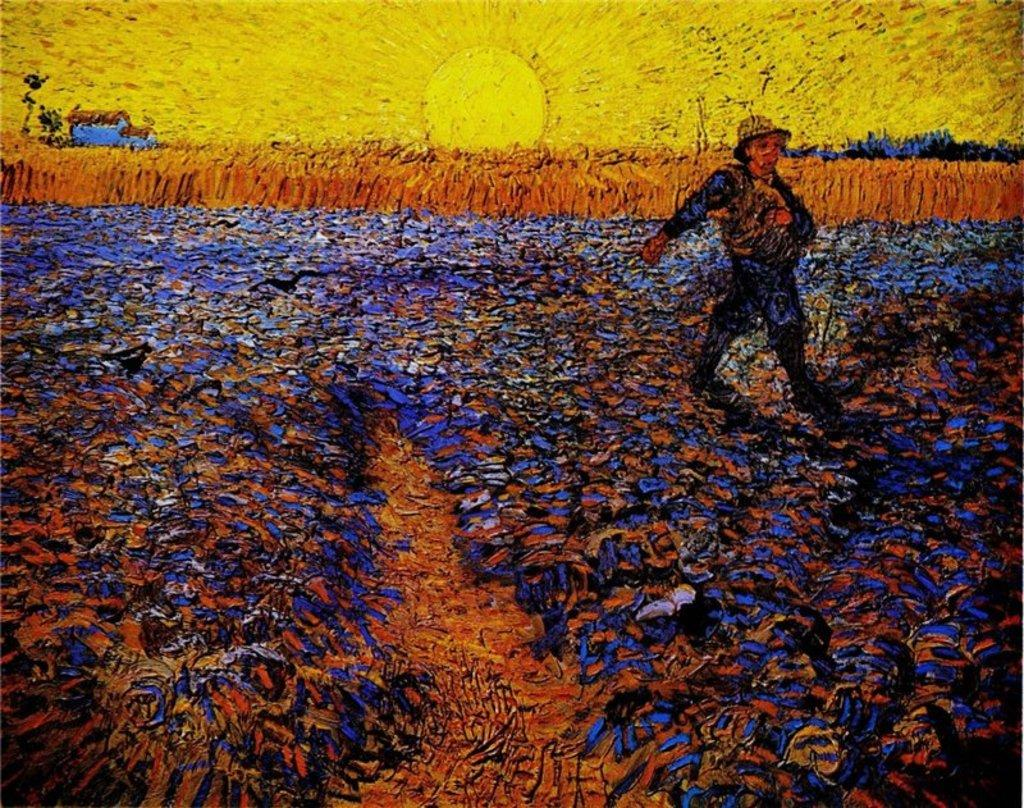What is depicted in the artwork in the image? The facts provided do not give information about the artwork's content. What time of day is depicted in the image? There is a sunrise in the image, indicating that it is early morning. What type of landscape is shown in the image? Crops are visible in the image, suggesting a rural or agricultural setting. What is the person in the image doing? A person is walking in between the crops in the image. What type of stone is being hammered by the person in the image? There is no person hammering a stone in the image; the person is walking in between the crops. 